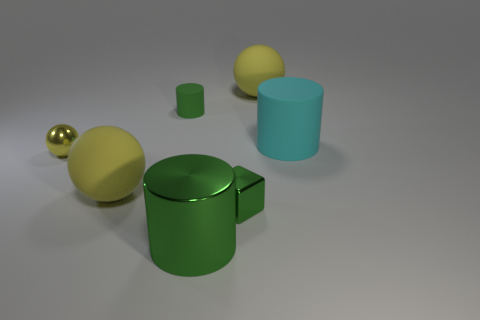How many yellow spheres must be subtracted to get 1 yellow spheres? 2 Subtract all green cylinders. How many cylinders are left? 1 Add 1 small cylinders. How many objects exist? 8 Subtract all cyan cylinders. How many cylinders are left? 2 Subtract all red balls. How many green cylinders are left? 2 Subtract all cubes. How many objects are left? 6 Subtract 2 cylinders. How many cylinders are left? 1 Add 1 tiny cubes. How many tiny cubes exist? 2 Subtract 0 red spheres. How many objects are left? 7 Subtract all blue cylinders. Subtract all yellow spheres. How many cylinders are left? 3 